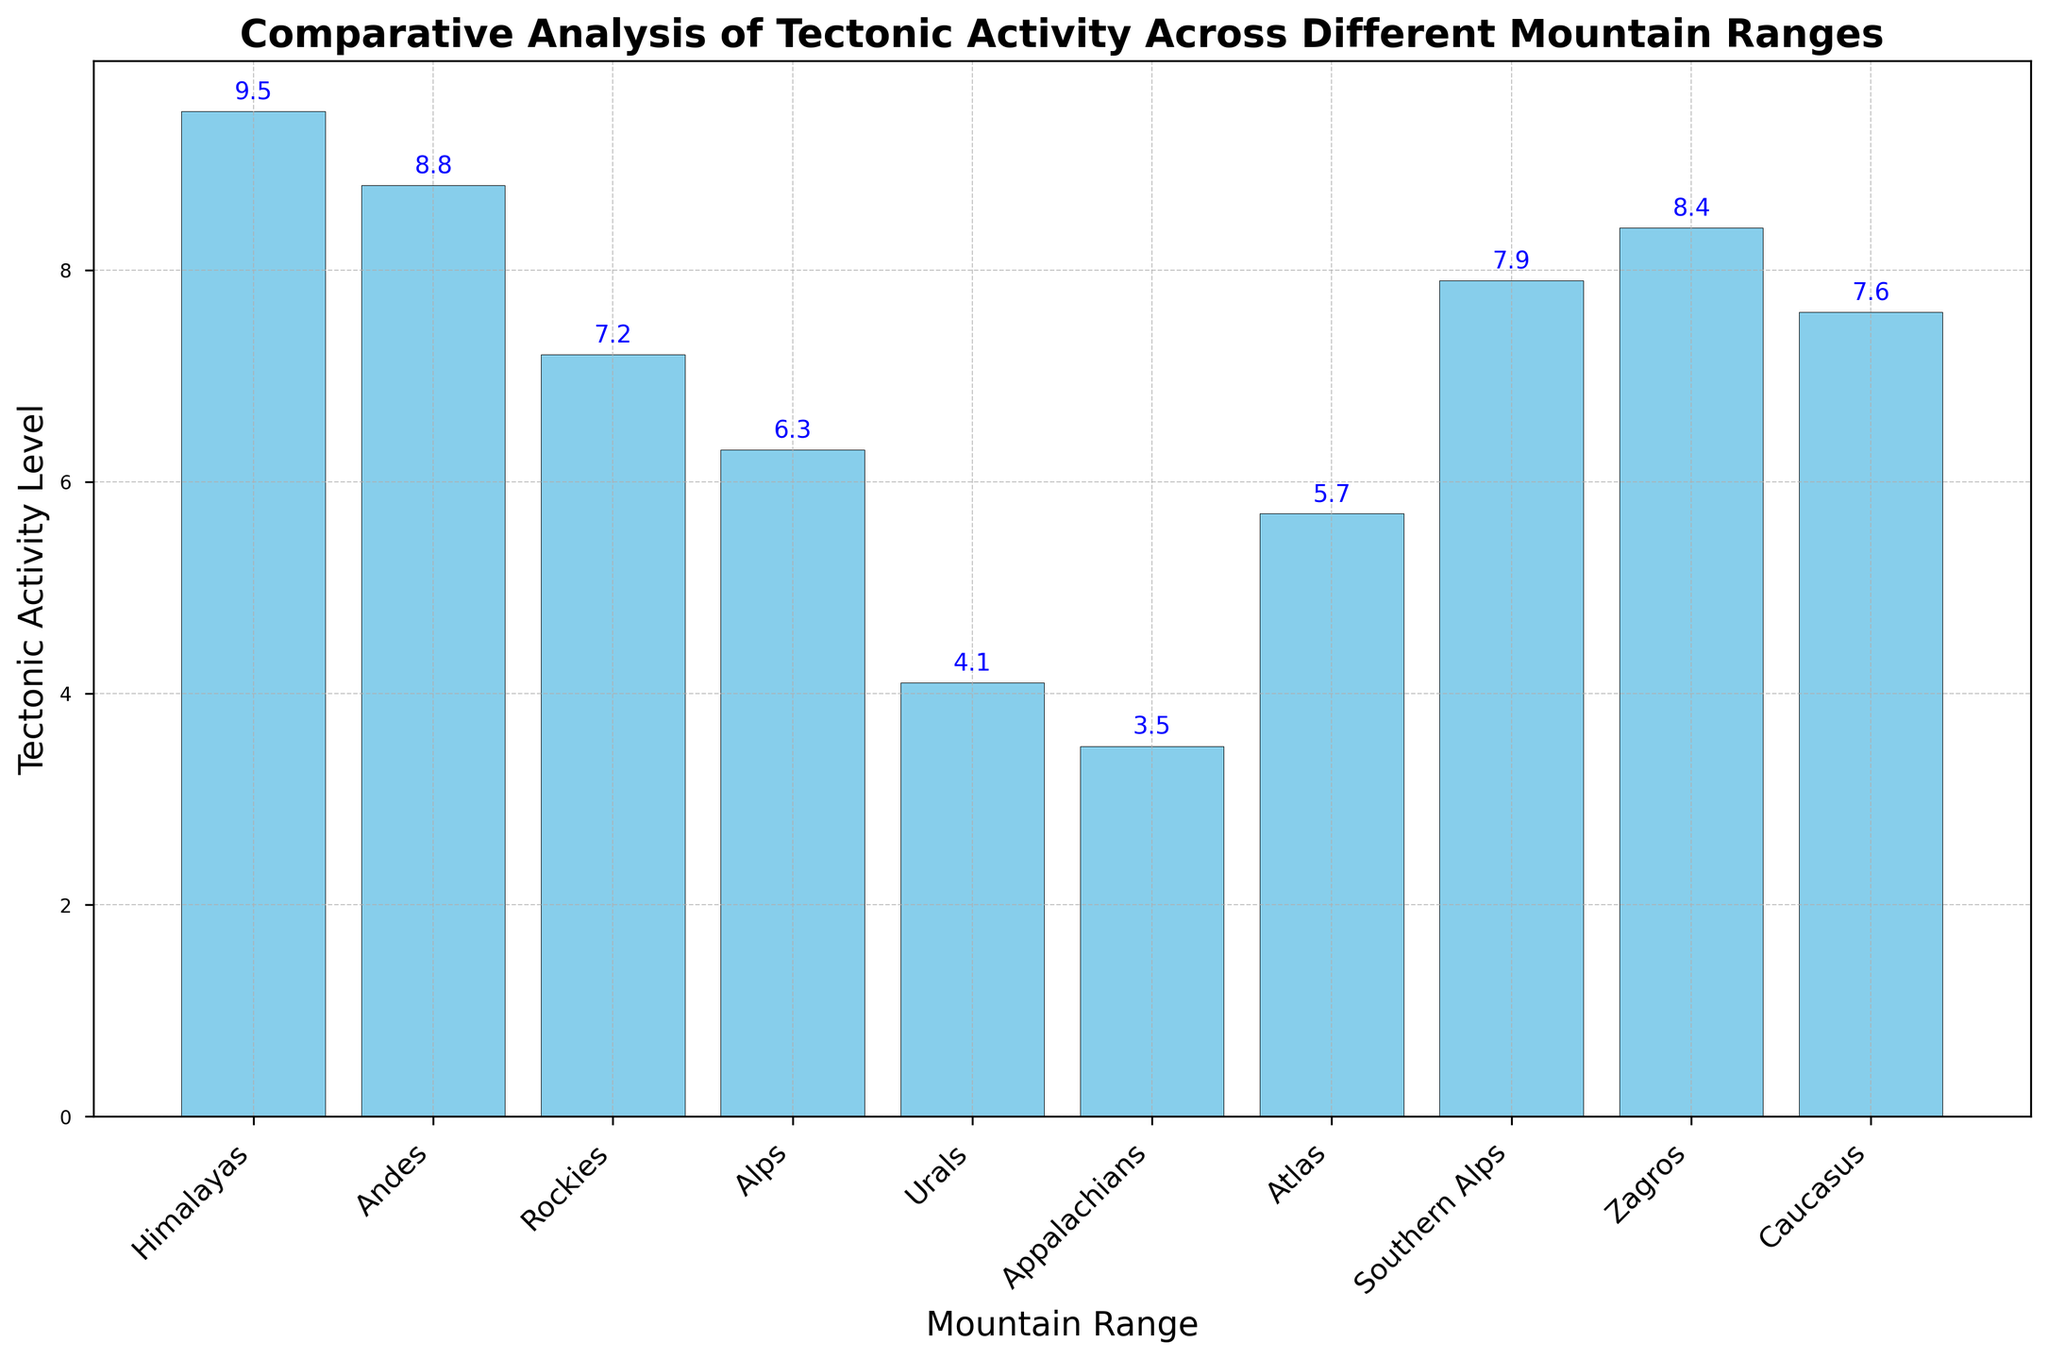Which mountain range has the highest tectonic activity level? The figure shows multiple bars representing tectonic activity levels for each mountain range. By examining the tallest bar, we see that the Himalayas has the highest value.
Answer: Himalayas Which mountain range has the lowest tectonic activity level? The figure shows multiple bars, with the shortest bar representing the lowest activity. The Appalachians have the shortest bar.
Answer: Appalachians What is the difference in tectonic activity levels between the Andes and the Atlas mountains? The Andes have a tectonic activity level of 8.8 and the Atlas mountains have a level of 5.7. Subtracting 5.7 from 8.8 gives the difference.
Answer: 3.1 What is the average tectonic activity level of all the mountain ranges? Sum all the tectonic activity levels: (9.5 + 8.8 + 7.2 + 6.3 + 4.1 + 3.5 + 5.7 + 7.9 + 8.4 + 7.6) = 69. Subtract the sum by the total number of data points, which is 10: 69 / 10 gives the average.
Answer: 6.9 Which region has the highest tectonic activity level? Identify the regions corresponding to the highest tectonic activity levels. The Himalayas, located in Asia, have the highest level (9.5), making Asia the region with the highest tectonic activity level.
Answer: Asia Is the tectonic activity level of the Rockies greater than that of the Caucasus? The Rockies have a tectonic activity level of 7.2, while the Caucasus have a level of 7.6. Comparing these levels shows that 7.2 is less than 7.6.
Answer: No What is the sum of the tectonic activity levels for the mountain ranges located in Europe? Europe contains the Alps (6.3), Urals (4.1), and part of the Caucasus (7.6). Adding these values together: 6.3 + 4.1 + 7.6.
Answer: 18 How many mountain ranges have a tectonic activity level greater than 7? Counting the bars above the level of 7: Himalayas (9.5), Andes (8.8), Southern Alps (7.9), Zagros (8.4), and Caucasus (7.6).
Answer: 5 Which mountain range is closer in tectonic activity level to the Southern Alps: the Rockies or the Alps? Southern Alps have a level of 7.9. The Rockies have 7.2, and the Alps have 6.3. Subtracting these gives differences of 0.7 and 1.6 respectively, so the Rockies are closer.
Answer: Rockies What is the combined tectonic activity level for mountain ranges in North America? North America contains the Rockies (7.2) and the Appalachians (3.5). Adding these together gives: 7.2 + 3.5.
Answer: 10.7 